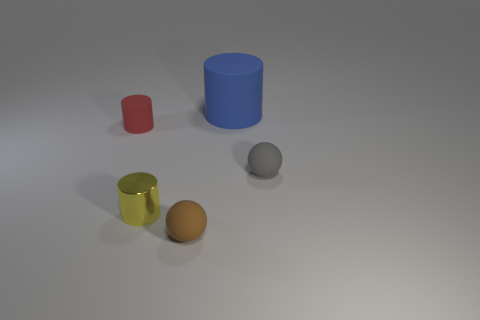Subtract all tiny cylinders. How many cylinders are left? 1 Subtract 1 cylinders. How many cylinders are left? 2 Add 3 tiny gray matte cylinders. How many objects exist? 8 Subtract all balls. How many objects are left? 3 Subtract all tiny shiny cylinders. Subtract all small metal blocks. How many objects are left? 4 Add 2 big matte things. How many big matte things are left? 3 Add 2 small gray matte balls. How many small gray matte balls exist? 3 Subtract 0 blue blocks. How many objects are left? 5 